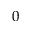<formula> <loc_0><loc_0><loc_500><loc_500>0</formula> 